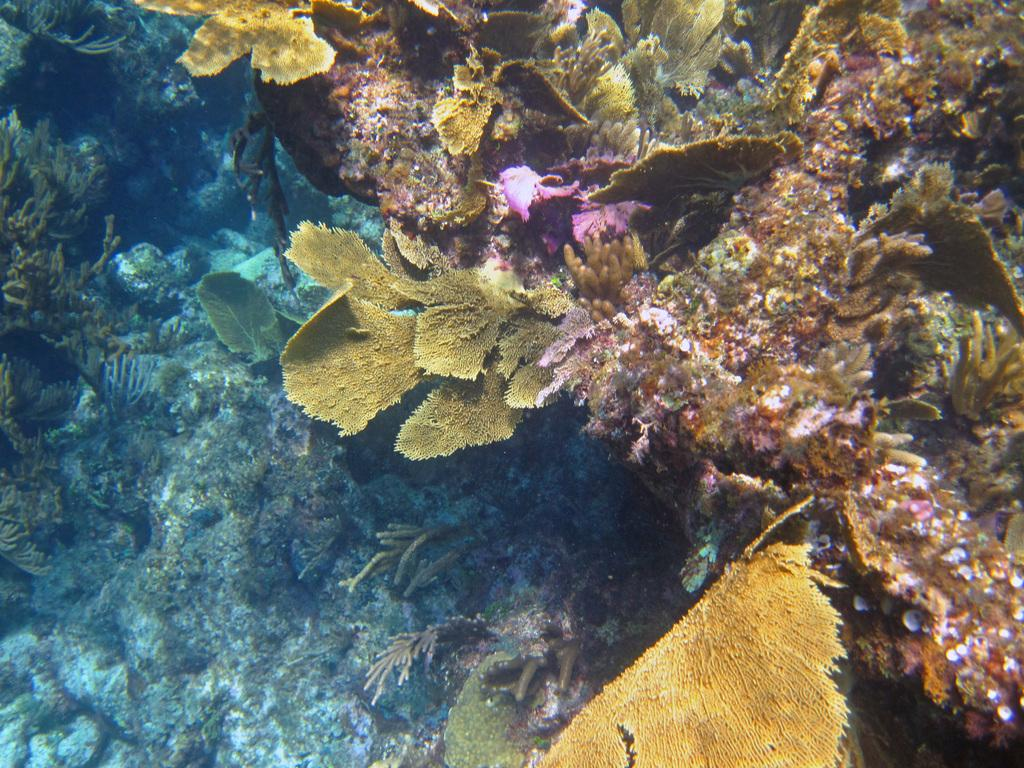What type of plants are in the image? There are plants in the water in the image. Can you describe the environment in which the plants are located? The plants are in the water. What type of clouds can be seen in the image? There are no clouds visible in the image, as it features plants in the water. 